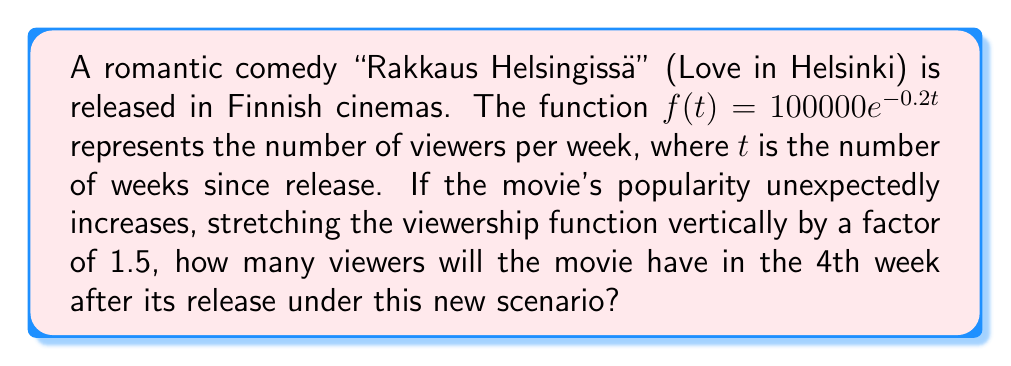Show me your answer to this math problem. Let's approach this step-by-step:

1) The original function is $f(t) = 100000e^{-0.2t}$

2) A vertical stretch by a factor of 1.5 is represented by multiplying the function by 1.5:
   $g(t) = 1.5f(t) = 1.5 \cdot 100000e^{-0.2t} = 150000e^{-0.2t}$

3) We want to find the number of viewers in the 4th week, so we need to calculate $g(4)$:
   $g(4) = 150000e^{-0.2(4)}$

4) Let's simplify the exponent:
   $g(4) = 150000e^{-0.8}$

5) Using a calculator or computer to evaluate this:
   $g(4) \approx 67032.0$

6) Since we're dealing with viewers, we should round to the nearest whole number:
   $g(4) \approx 67032$ viewers
Answer: 67032 viewers 